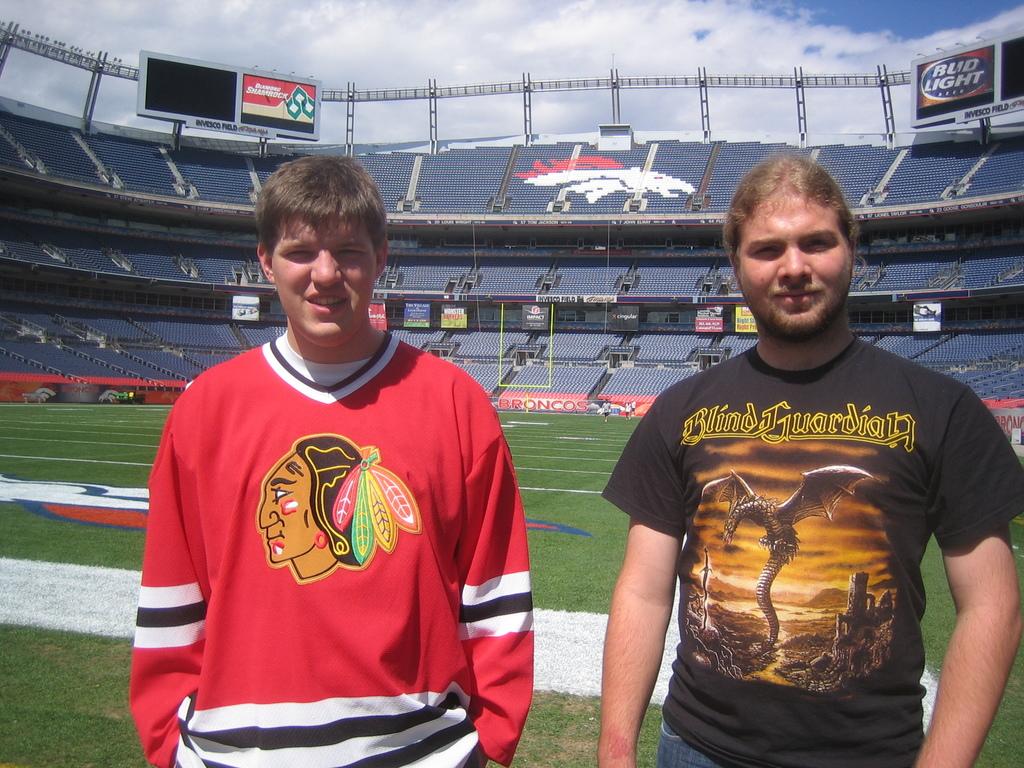Who is the band on the man's black shirt?
Offer a very short reply. Blind guardian. Which nfl team plays their home games in this stadium?
Ensure brevity in your answer.  Broncos. 